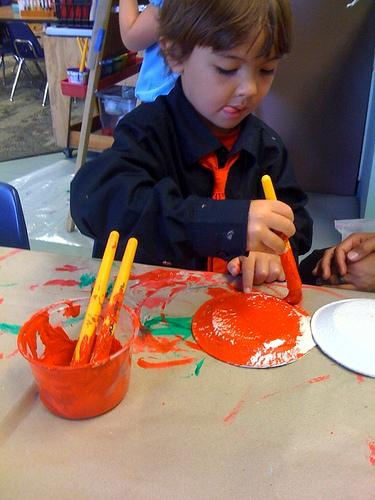Which one of the paint is safe for children art work? orange 